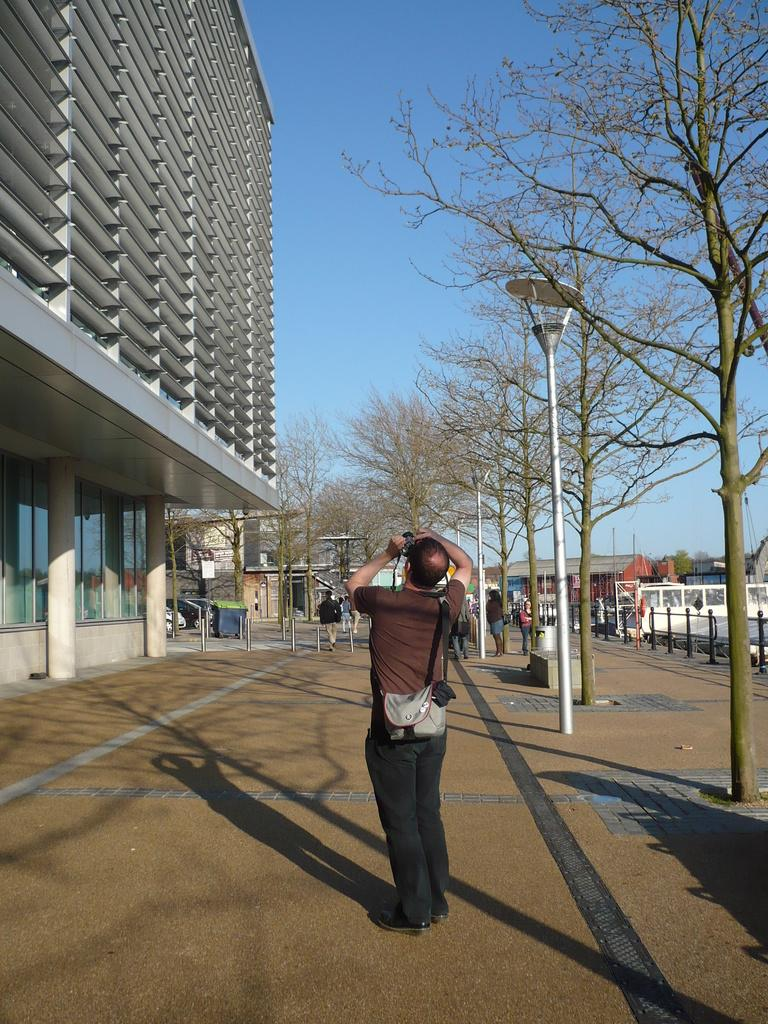How many people are present in the image? There are people in the image, but the exact number is not specified. What can be seen in the image besides people? There are poles, trees, buildings, vehicles, and objects in the image. What is visible in the background of the image? The sky is visible in the image. Can you describe the objects in the image? The objects in the image are not specified, but there are poles, trees, buildings, vehicles, and a person holding an object. What is the person in the front of the image holding? A person is holding an object in the front of the image. What is the person wearing on their body? The person is wearing a bag. What type of feast is being prepared in the image? There is no indication of a feast or any food preparation in the image. Is it raining in the image? The weather conditions are not mentioned in the image, so we cannot determine if it is raining or not. What type of oatmeal is being served in the image? There is no oatmeal or any food items mentioned in the image. 